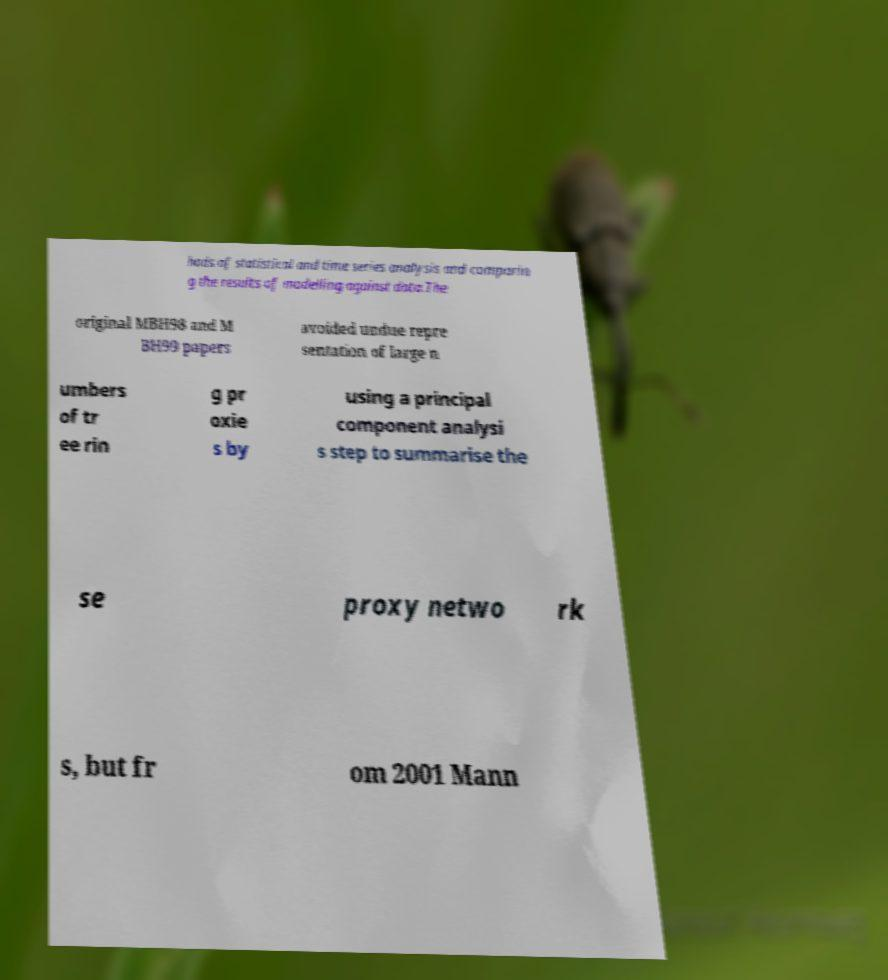There's text embedded in this image that I need extracted. Can you transcribe it verbatim? hods of statistical and time series analysis and comparin g the results of modelling against data.The original MBH98 and M BH99 papers avoided undue repre sentation of large n umbers of tr ee rin g pr oxie s by using a principal component analysi s step to summarise the se proxy netwo rk s, but fr om 2001 Mann 